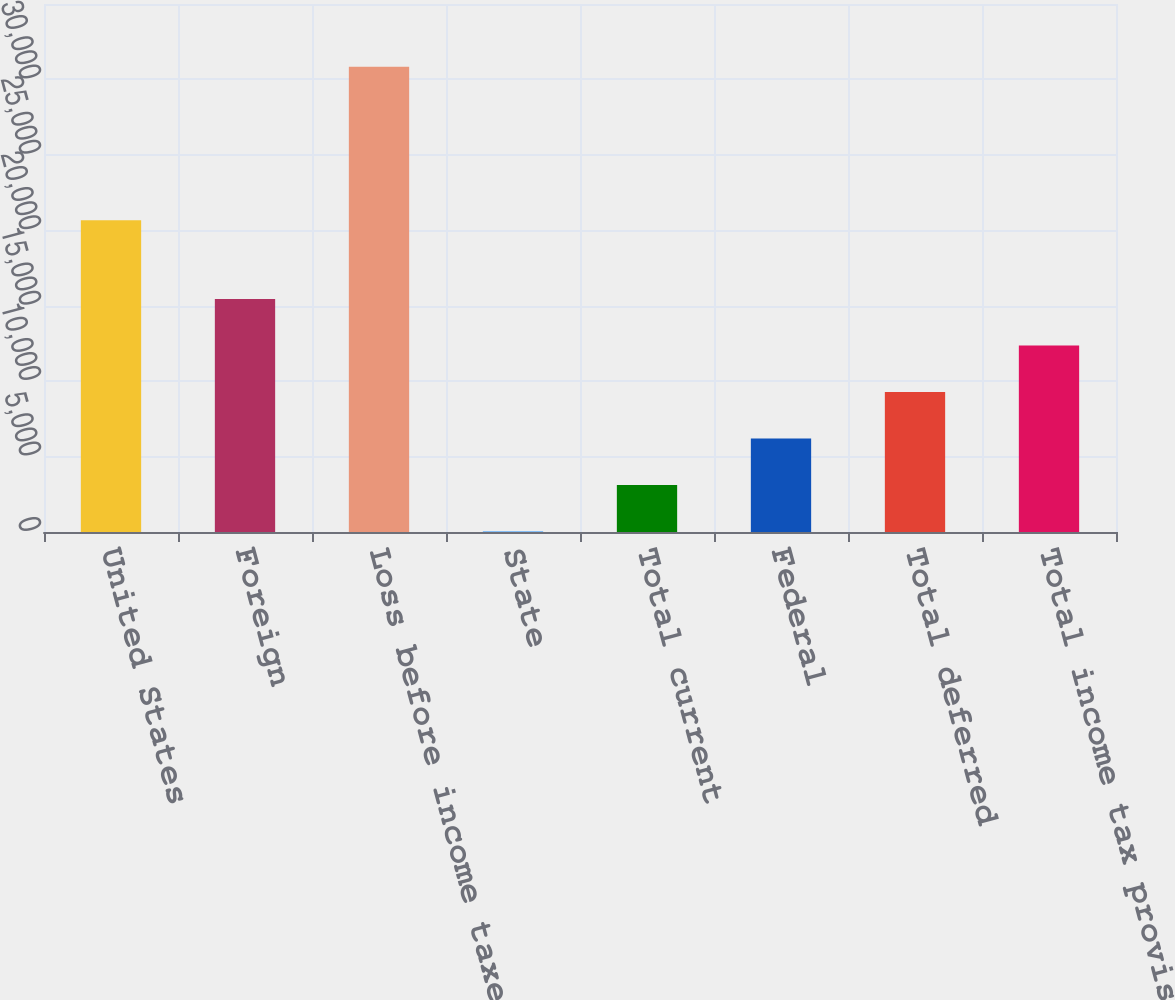Convert chart to OTSL. <chart><loc_0><loc_0><loc_500><loc_500><bar_chart><fcel>United States<fcel>Foreign<fcel>Loss before income taxes<fcel>State<fcel>Total current<fcel>Federal<fcel>Total deferred<fcel>Total income tax provision<nl><fcel>20672<fcel>15438.5<fcel>30845<fcel>32<fcel>3113.3<fcel>6194.6<fcel>9275.9<fcel>12357.2<nl></chart> 